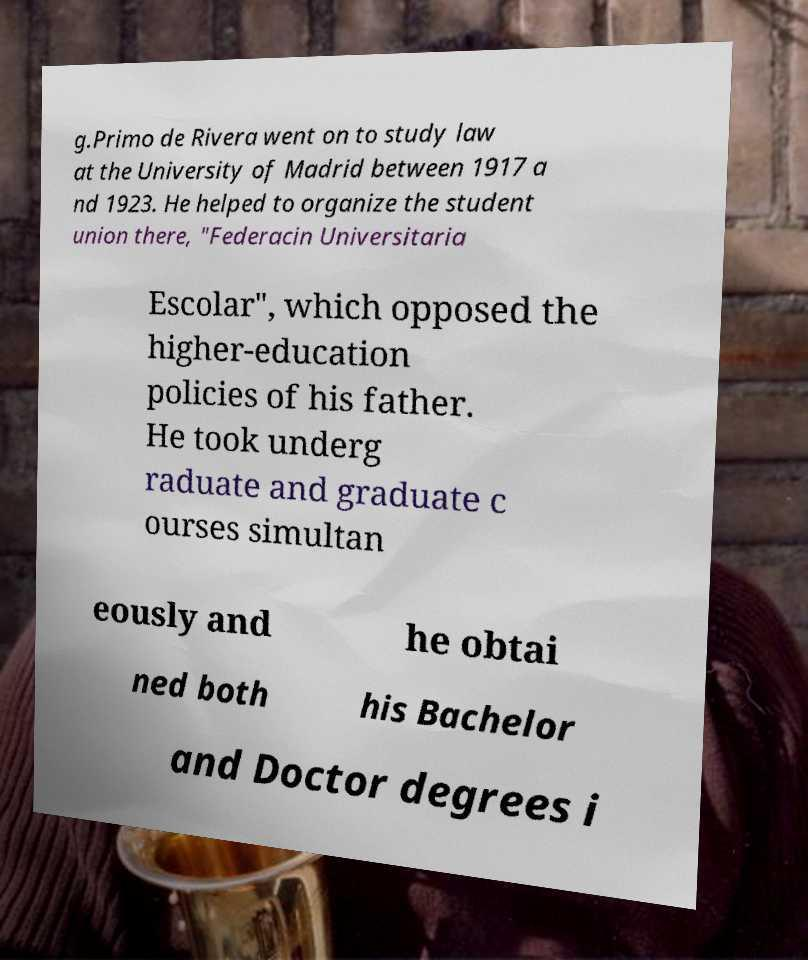Please read and relay the text visible in this image. What does it say? g.Primo de Rivera went on to study law at the University of Madrid between 1917 a nd 1923. He helped to organize the student union there, "Federacin Universitaria Escolar", which opposed the higher-education policies of his father. He took underg raduate and graduate c ourses simultan eously and he obtai ned both his Bachelor and Doctor degrees i 